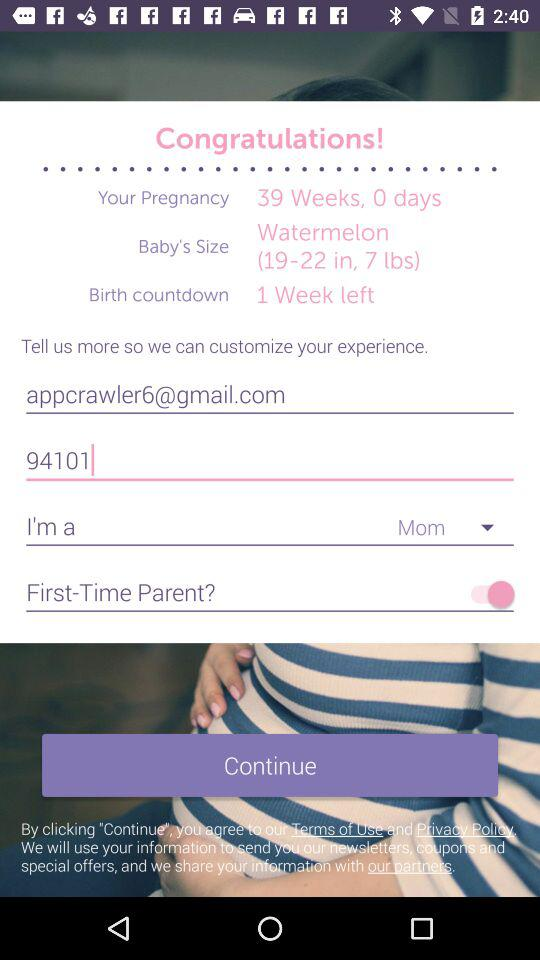How many more days until the due date?
Answer the question using a single word or phrase. 1 week 